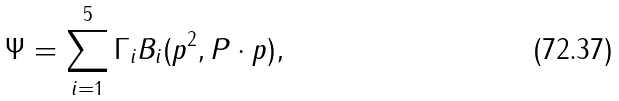<formula> <loc_0><loc_0><loc_500><loc_500>\Psi = \sum _ { i = 1 } ^ { 5 } \Gamma _ { i } B _ { i } ( p ^ { 2 } , P \cdot p ) ,</formula> 